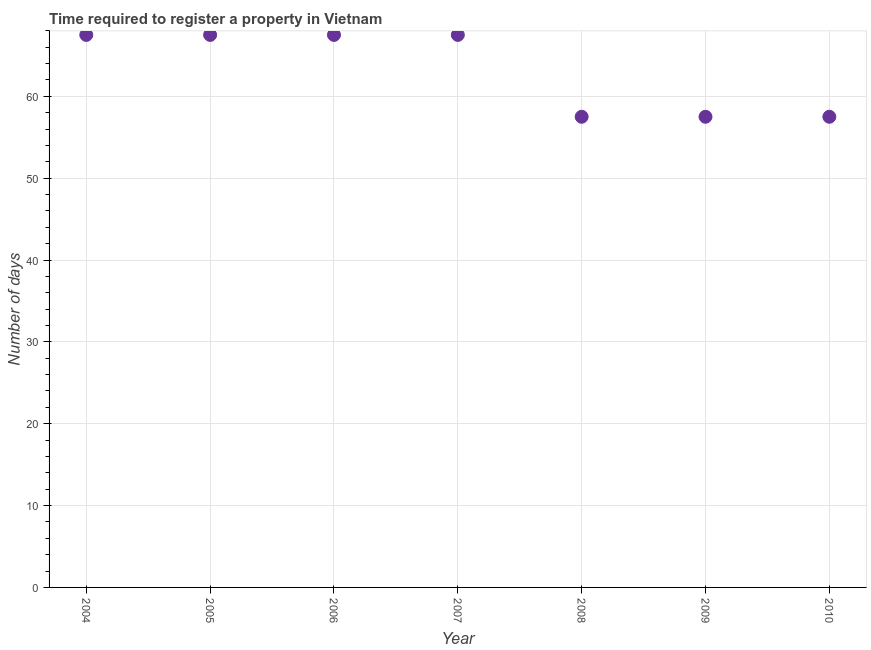What is the number of days required to register property in 2004?
Provide a short and direct response. 67.5. Across all years, what is the maximum number of days required to register property?
Ensure brevity in your answer.  67.5. Across all years, what is the minimum number of days required to register property?
Provide a succinct answer. 57.5. What is the sum of the number of days required to register property?
Offer a very short reply. 442.5. What is the average number of days required to register property per year?
Make the answer very short. 63.21. What is the median number of days required to register property?
Make the answer very short. 67.5. What is the ratio of the number of days required to register property in 2004 to that in 2009?
Provide a short and direct response. 1.17. Is the sum of the number of days required to register property in 2006 and 2008 greater than the maximum number of days required to register property across all years?
Your answer should be compact. Yes. What is the difference between the highest and the lowest number of days required to register property?
Provide a short and direct response. 10. In how many years, is the number of days required to register property greater than the average number of days required to register property taken over all years?
Make the answer very short. 4. How many dotlines are there?
Keep it short and to the point. 1. Does the graph contain grids?
Your response must be concise. Yes. What is the title of the graph?
Offer a terse response. Time required to register a property in Vietnam. What is the label or title of the X-axis?
Offer a very short reply. Year. What is the label or title of the Y-axis?
Provide a short and direct response. Number of days. What is the Number of days in 2004?
Your answer should be compact. 67.5. What is the Number of days in 2005?
Your answer should be compact. 67.5. What is the Number of days in 2006?
Ensure brevity in your answer.  67.5. What is the Number of days in 2007?
Make the answer very short. 67.5. What is the Number of days in 2008?
Ensure brevity in your answer.  57.5. What is the Number of days in 2009?
Provide a succinct answer. 57.5. What is the Number of days in 2010?
Give a very brief answer. 57.5. What is the difference between the Number of days in 2004 and 2006?
Keep it short and to the point. 0. What is the difference between the Number of days in 2005 and 2006?
Provide a short and direct response. 0. What is the difference between the Number of days in 2005 and 2009?
Keep it short and to the point. 10. What is the difference between the Number of days in 2005 and 2010?
Give a very brief answer. 10. What is the difference between the Number of days in 2006 and 2008?
Your answer should be very brief. 10. What is the difference between the Number of days in 2007 and 2009?
Your answer should be very brief. 10. What is the difference between the Number of days in 2008 and 2010?
Provide a short and direct response. 0. What is the difference between the Number of days in 2009 and 2010?
Give a very brief answer. 0. What is the ratio of the Number of days in 2004 to that in 2008?
Provide a short and direct response. 1.17. What is the ratio of the Number of days in 2004 to that in 2009?
Offer a terse response. 1.17. What is the ratio of the Number of days in 2004 to that in 2010?
Offer a very short reply. 1.17. What is the ratio of the Number of days in 2005 to that in 2006?
Provide a short and direct response. 1. What is the ratio of the Number of days in 2005 to that in 2008?
Ensure brevity in your answer.  1.17. What is the ratio of the Number of days in 2005 to that in 2009?
Ensure brevity in your answer.  1.17. What is the ratio of the Number of days in 2005 to that in 2010?
Your answer should be compact. 1.17. What is the ratio of the Number of days in 2006 to that in 2007?
Offer a terse response. 1. What is the ratio of the Number of days in 2006 to that in 2008?
Make the answer very short. 1.17. What is the ratio of the Number of days in 2006 to that in 2009?
Offer a terse response. 1.17. What is the ratio of the Number of days in 2006 to that in 2010?
Your response must be concise. 1.17. What is the ratio of the Number of days in 2007 to that in 2008?
Keep it short and to the point. 1.17. What is the ratio of the Number of days in 2007 to that in 2009?
Your answer should be very brief. 1.17. What is the ratio of the Number of days in 2007 to that in 2010?
Your answer should be very brief. 1.17. What is the ratio of the Number of days in 2009 to that in 2010?
Ensure brevity in your answer.  1. 